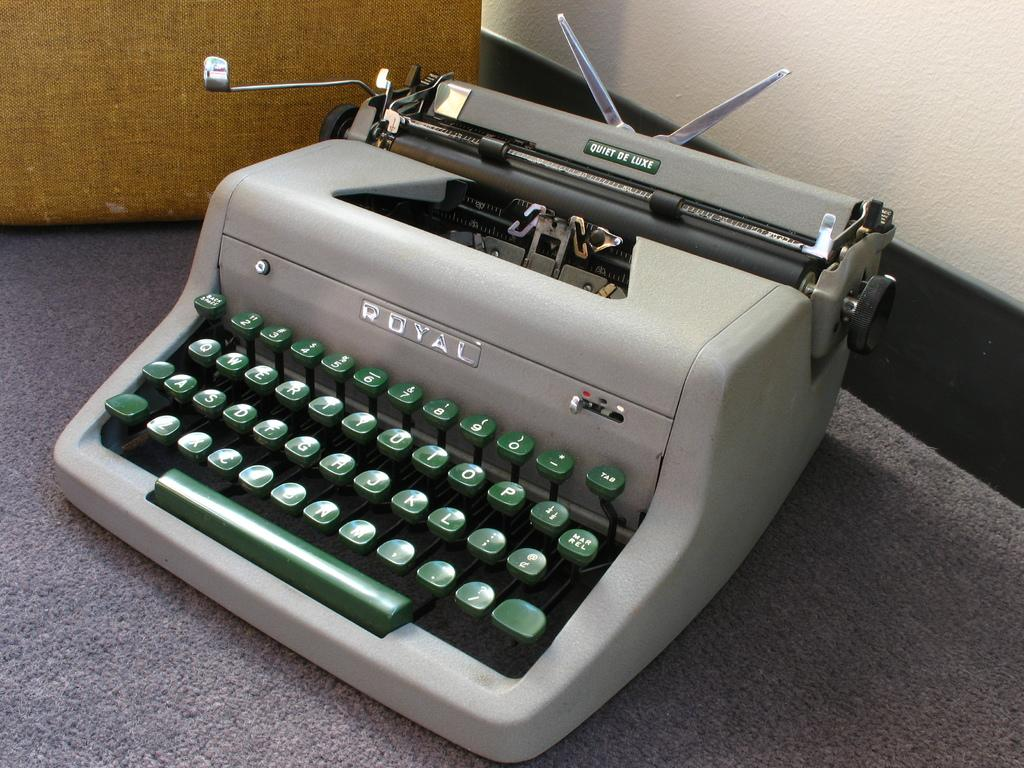<image>
Write a terse but informative summary of the picture. An old school Royal typewriter that is the Quiet De Luxe model 